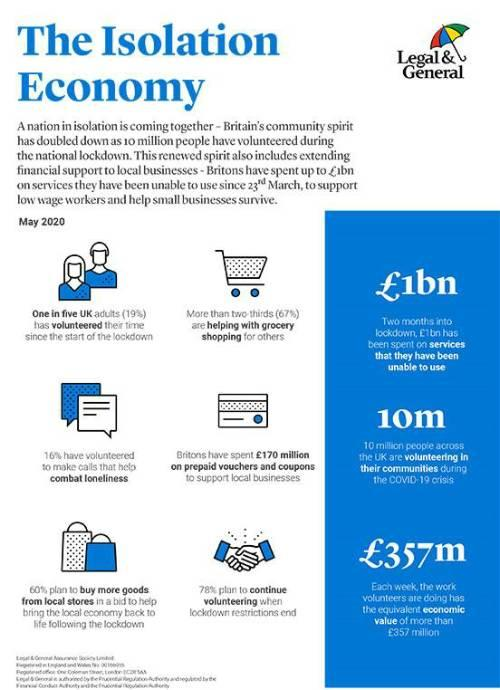Draw attention to some important aspects in this diagram. Two-thirds of the population in the United Kingdom are contributing to the welfare of others by engaging in acts of kindness, such as grocery shopping, to aid those in need. Volunteering to make calls was helpful in combating loneliness. Spending money on vouchers and coupons was beneficial for local businesses. According to recent data, over 19% of adults in the UK have volunteered their time since the onset of the lockdown. I propose that we revive our local economy by encouraging the people to support local businesses by buying more goods from local stores. 